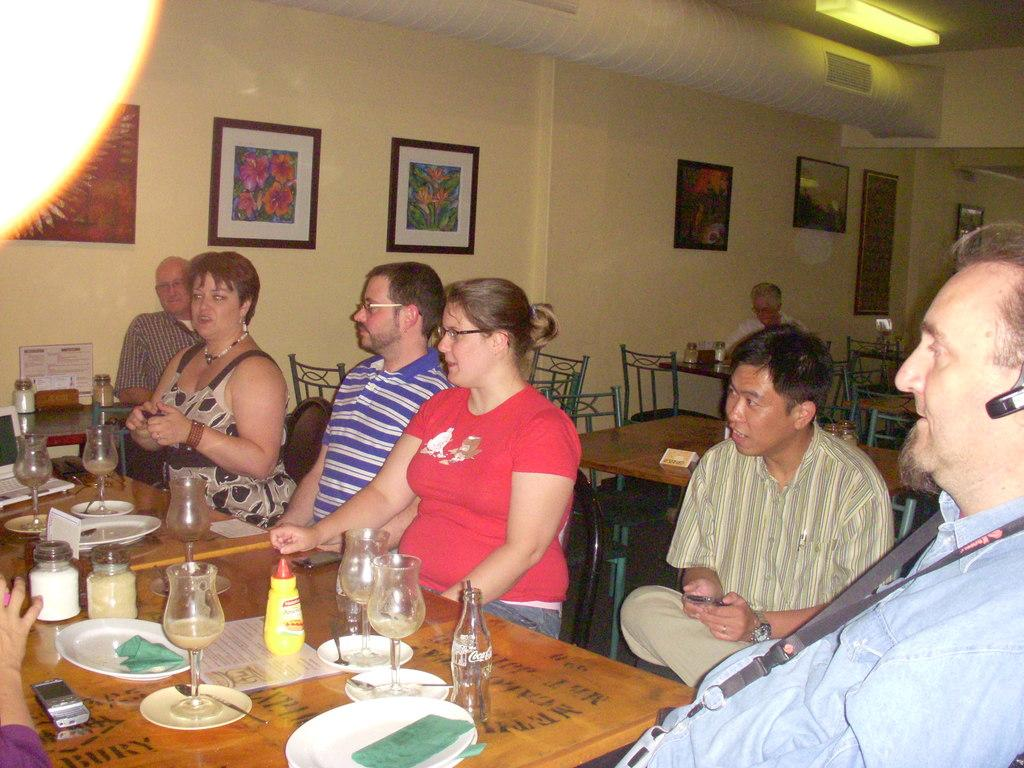What are the people in the image doing? The people in the image are sitting on chairs. What objects can be seen on the table in the image? There are plates, glasses, and a bottle on the table in the image. What is present on the wall in the image? There are frames on the wall in the image. Who is arguing with the uncle in the image? There is no uncle or argument present in the image. What type of smile can be seen on the people's faces in the image? The image does not show the people's facial expressions, so it is not possible to determine if they are smiling or not. 